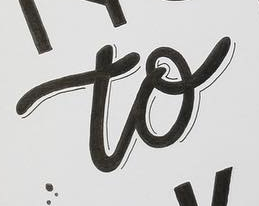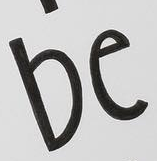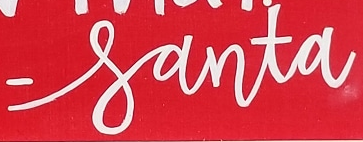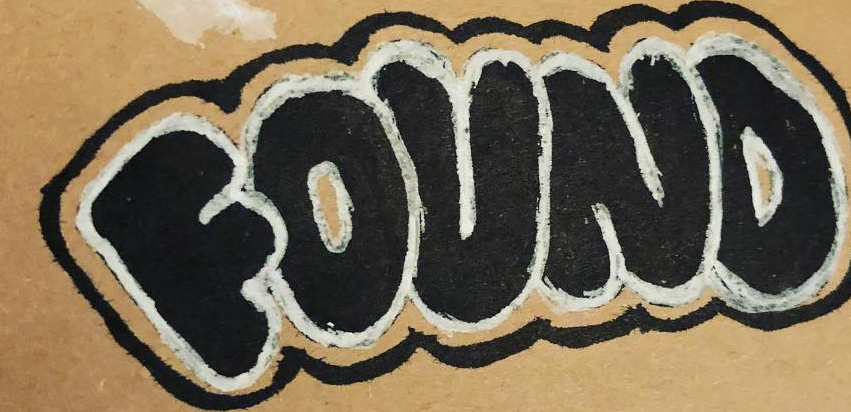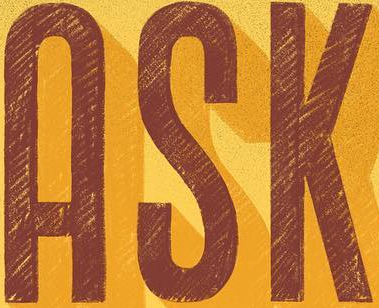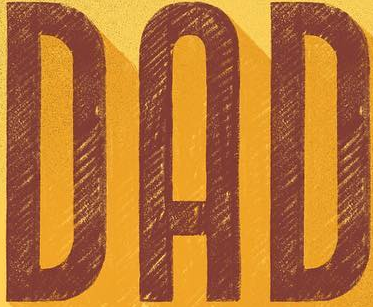What words are shown in these images in order, separated by a semicolon? to; be; -santa; FOUND; ASK; DAD 